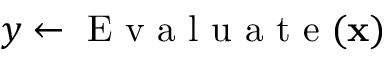<formula> <loc_0><loc_0><loc_500><loc_500>y \gets E v a l u a t e ( x )</formula> 